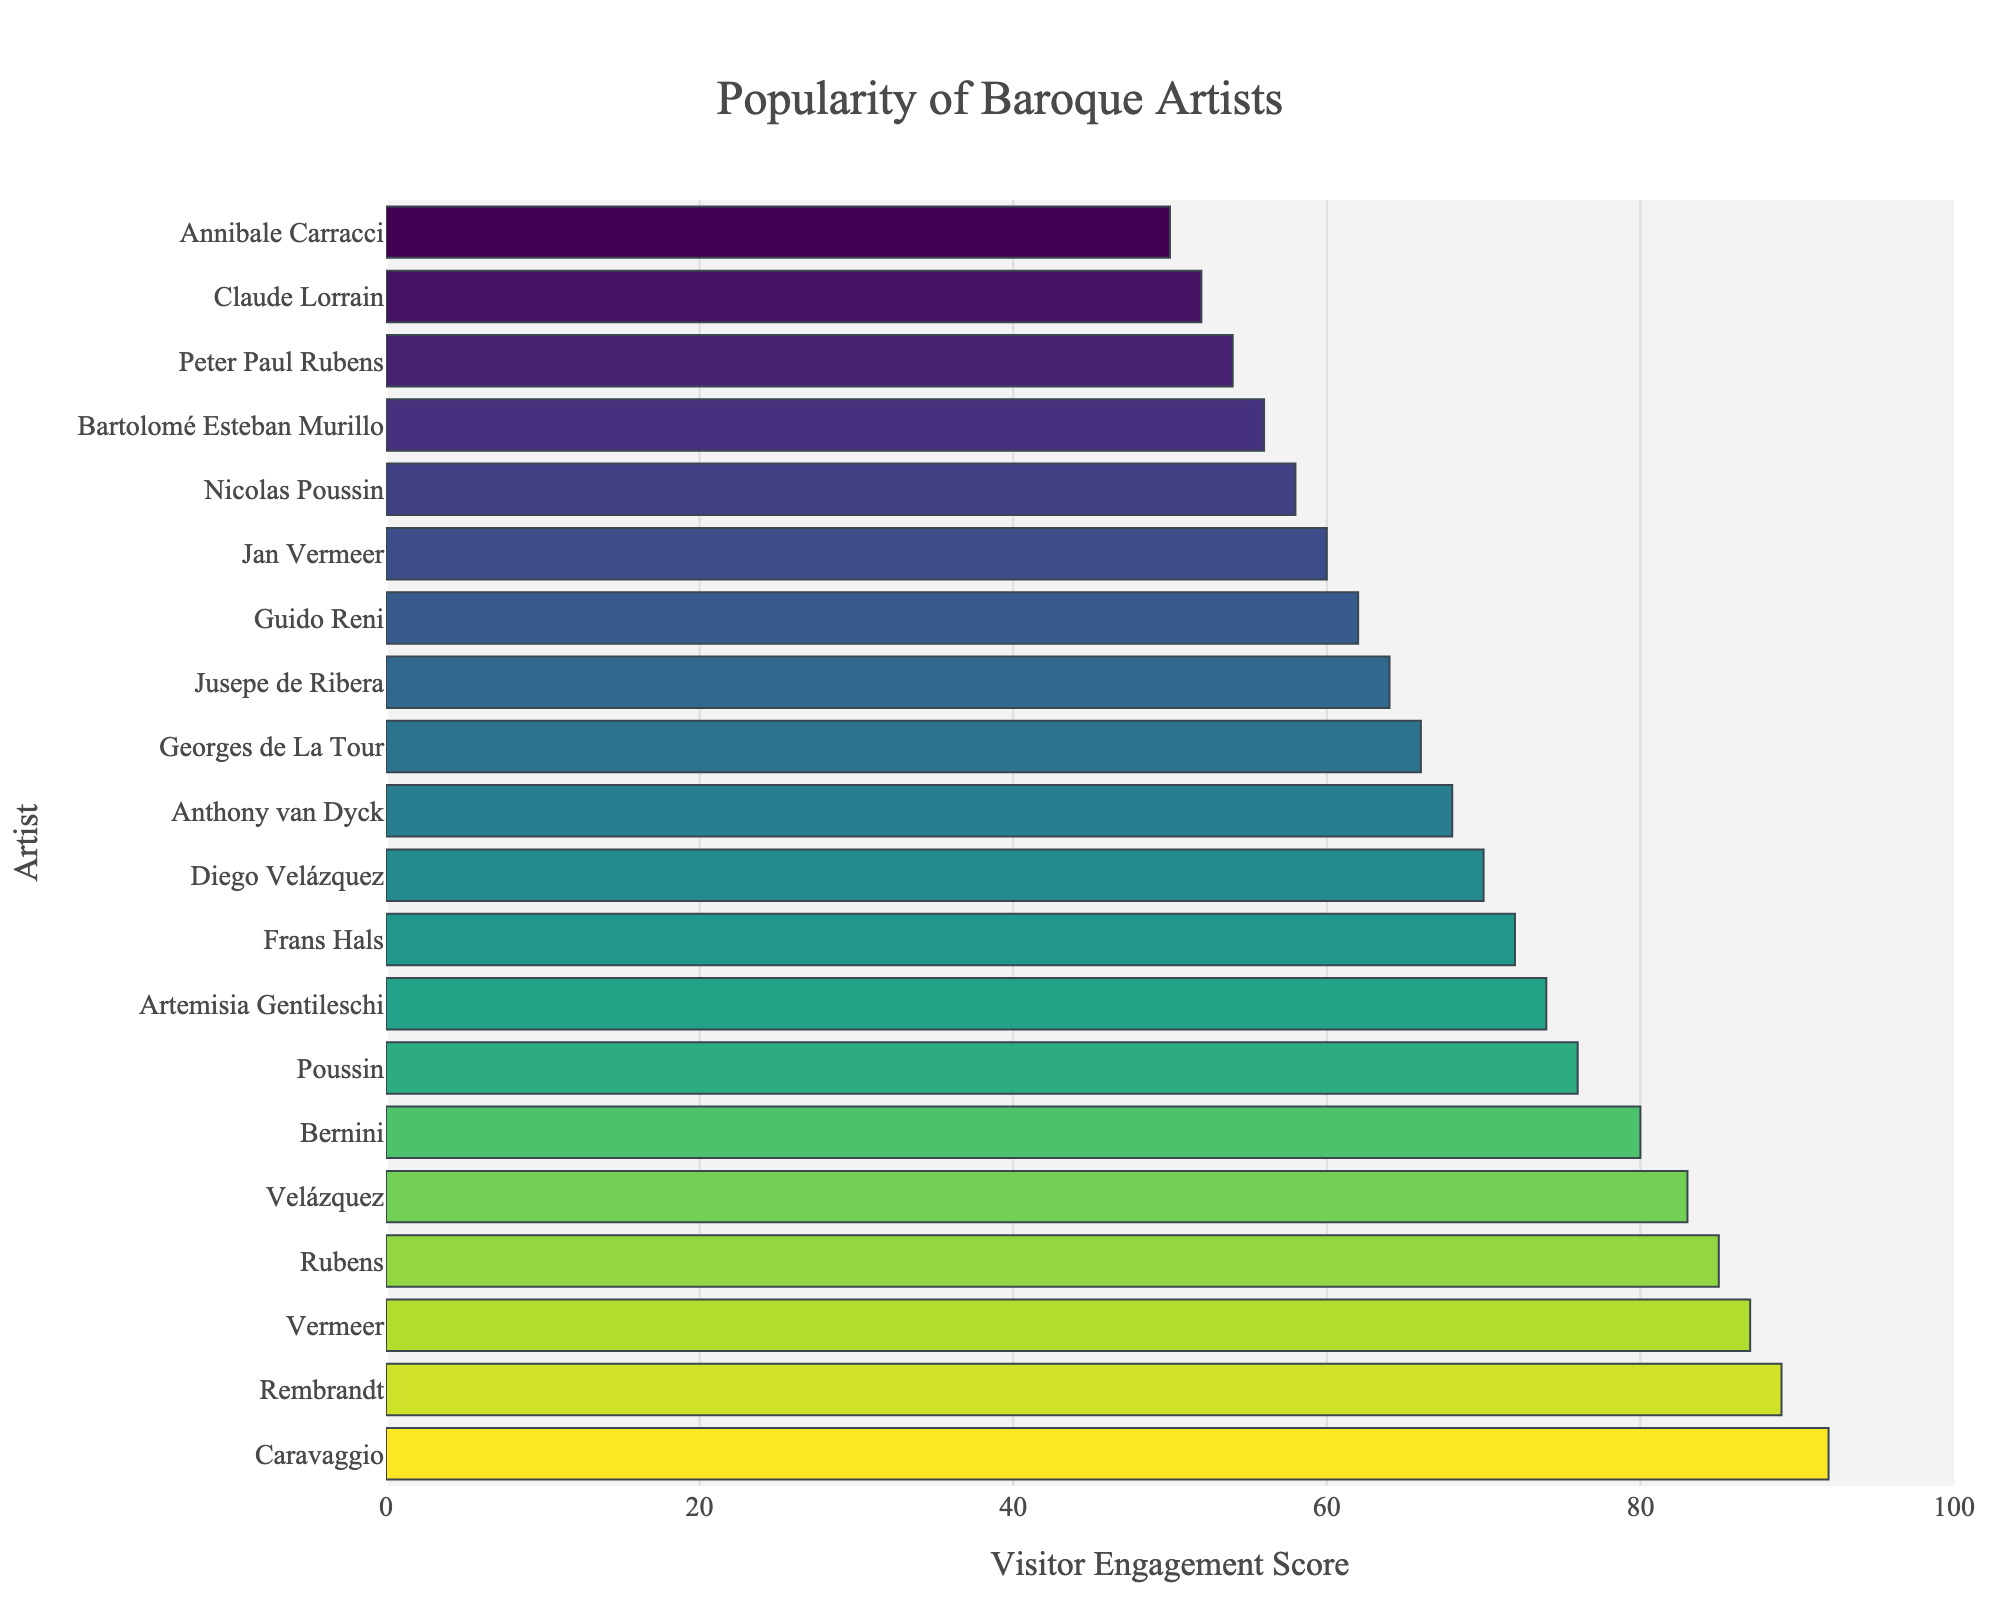Who is the most popular Baroque artist based on visitor engagement? The artist with the highest Visitor Engagement Score is the most popular. According to the chart, Caravaggio has the highest score of 92.
Answer: Caravaggio Which two artists have the closest Visitor Engagement Scores? Compare the adjacent scores on the plotted bars. Vermeer and Rubens have scores of 87 and 85, respectively, showing the least difference of just 2 points.
Answer: Vermeer and Rubens What is the difference in Visitor Engagement Score between Caravaggio and Artemisia Gentileschi? Subtract the score of Artemisia Gentileschi (74) from Caravaggio's score (92). The difference is 92 - 74 = 18.
Answer: 18 Which artist has a Visitor Engagement Score closest to the median of all artists shown? With 20 artists, the median is the average of the 10th and 11th artists. Diego Velázquez (score 70) and Anthony van Dyck (score 68) are the 10th and 11th artists. The average is (70 + 68) / 2 = 69. The artist closest to this median is Anthony van Dyck with 68.
Answer: Anthony van Dyck How many artists have a Visitor Engagement Score above 80? Count the bars with scores greater than 80. Based on the visual information, there are 5 artists (Caravaggio, Rembrandt, Vermeer, Rubens, and Velázquez).
Answer: 5 Which artist has the lowest Visitor Engagement Score and what is it? The artist with the shortest bar has the lowest score. Annibale Carracci, with a score of 50, is the lowest.
Answer: Annibale Carracci, 50 What is the total Visitor Engagement Score of all artists displayed? Sum the scores of all artists. The calculated total is 92 + 89 + 87 + 85 + 83 + 80 + 76 + 74 + 72 + 70 + 68 + 66 + 64 + 62 + 60 + 58 + 56 + 54 + 52 + 50 = 1318.
Answer: 1318 Are there any artists with equal Visitor Engagement Scores, and if so, specify them? Look for artists with identical bar lengths. Both Diego Velázquez and Velázquez have scores of 83.
Answer: Diego Velázquez and Velázquez What is the average Visitor Engagement Score of the artists shown? Divide the total Visitor Engagement Score (1318) by the number of artists (20). 1318 / 20 = 65.9.
Answer: 65.9 